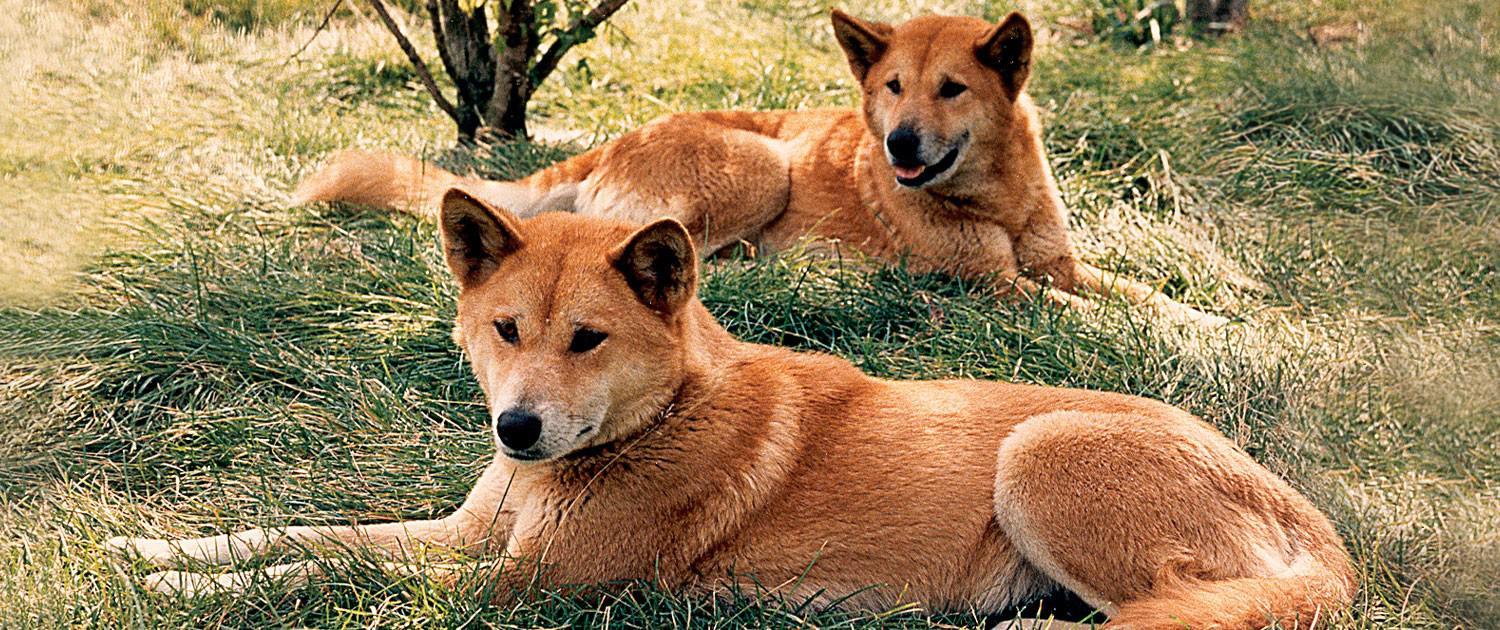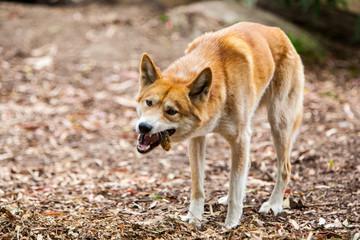The first image is the image on the left, the second image is the image on the right. Evaluate the accuracy of this statement regarding the images: "The left image includes exactly twice as many wild dogs as the right image.". Is it true? Answer yes or no. Yes. The first image is the image on the left, the second image is the image on the right. Evaluate the accuracy of this statement regarding the images: "At least one animal is lying down in one of the images.". Is it true? Answer yes or no. Yes. 